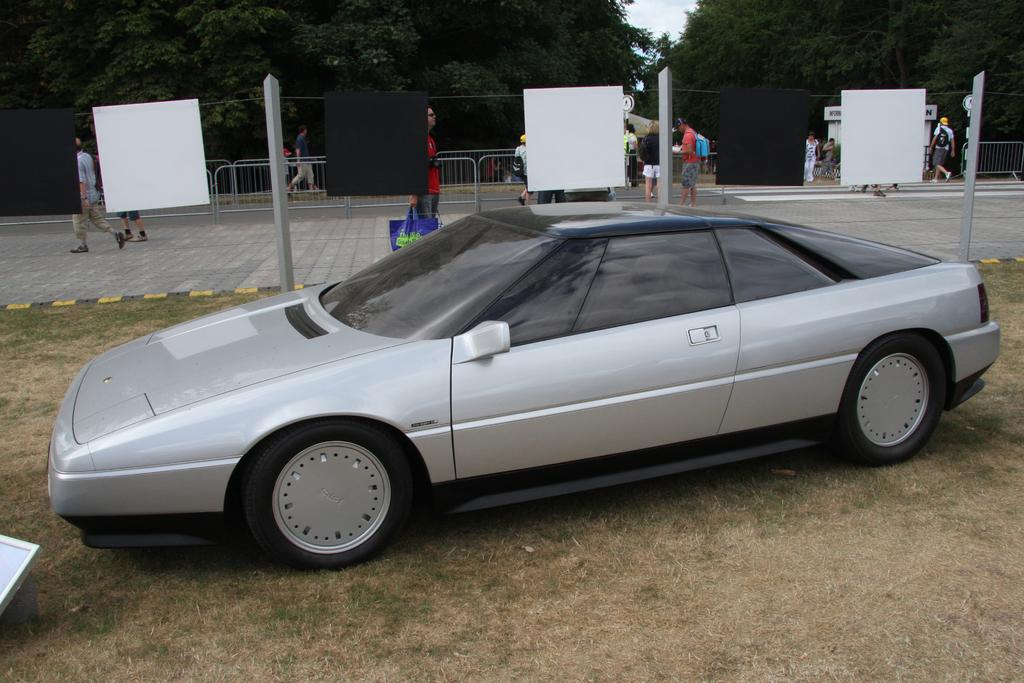What is the main subject of the image? There is a car in the image. What can be seen on the ground in the image? There is grass on the ground in the image. What is happening in the background of the image? There are people walking in the background of the image. What structures are present in the image? There are poles and railings in the image. What type of vegetation is visible in the background of the image? There are trees in the background of the image. How does the car start in the image? The image does not show the car starting; it only shows the car parked on the grass. What type of adjustment can be seen on the car's wheels in the image? There is no adjustment visible on the car's wheels in the image. 